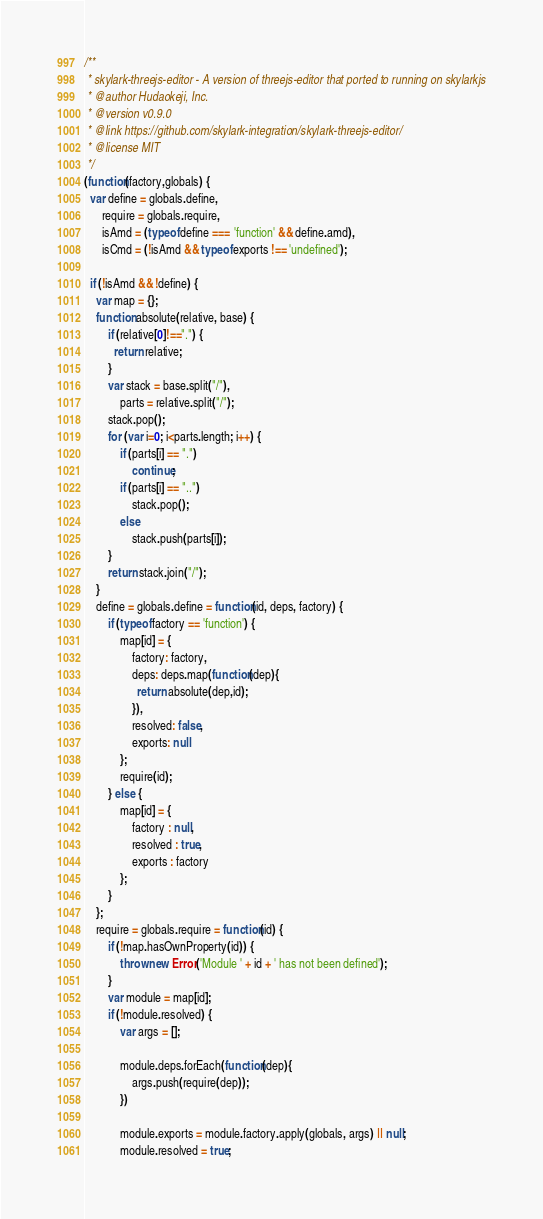<code> <loc_0><loc_0><loc_500><loc_500><_JavaScript_>/**
 * skylark-threejs-editor - A version of threejs-editor that ported to running on skylarkjs
 * @author Hudaokeji, Inc.
 * @version v0.9.0
 * @link https://github.com/skylark-integration/skylark-threejs-editor/
 * @license MIT
 */
(function(factory,globals) {
  var define = globals.define,
      require = globals.require,
      isAmd = (typeof define === 'function' && define.amd),
      isCmd = (!isAmd && typeof exports !== 'undefined');

  if (!isAmd && !define) {
    var map = {};
    function absolute(relative, base) {
        if (relative[0]!==".") {
          return relative;
        }
        var stack = base.split("/"),
            parts = relative.split("/");
        stack.pop(); 
        for (var i=0; i<parts.length; i++) {
            if (parts[i] == ".")
                continue;
            if (parts[i] == "..")
                stack.pop();
            else
                stack.push(parts[i]);
        }
        return stack.join("/");
    }
    define = globals.define = function(id, deps, factory) {
        if (typeof factory == 'function') {
            map[id] = {
                factory: factory,
                deps: deps.map(function(dep){
                  return absolute(dep,id);
                }),
                resolved: false,
                exports: null
            };
            require(id);
        } else {
            map[id] = {
                factory : null,
                resolved : true,
                exports : factory
            };
        }
    };
    require = globals.require = function(id) {
        if (!map.hasOwnProperty(id)) {
            throw new Error('Module ' + id + ' has not been defined');
        }
        var module = map[id];
        if (!module.resolved) {
            var args = [];

            module.deps.forEach(function(dep){
                args.push(require(dep));
            })

            module.exports = module.factory.apply(globals, args) || null;
            module.resolved = true;</code> 